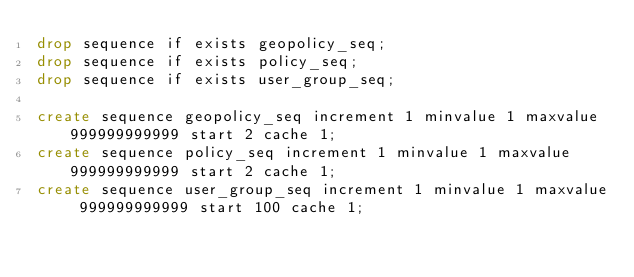<code> <loc_0><loc_0><loc_500><loc_500><_SQL_>drop sequence if exists geopolicy_seq;
drop sequence if exists policy_seq;
drop sequence if exists user_group_seq;

create sequence geopolicy_seq increment 1 minvalue 1 maxvalue 999999999999 start 2 cache 1;
create sequence policy_seq increment 1 minvalue 1 maxvalue 999999999999 start 2 cache 1;
create sequence user_group_seq increment 1 minvalue 1 maxvalue 999999999999 start 100 cache 1;
</code> 